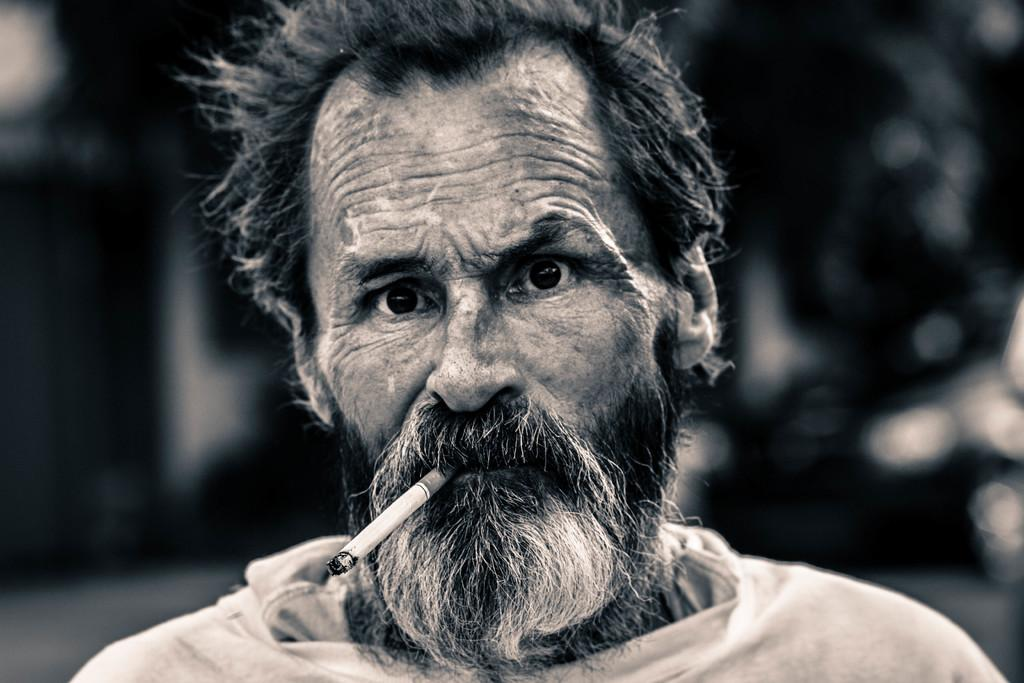What is present in the image? There is a person in the image. What is the person doing in the image? The person is holding a cigarette in their mouth. Can you describe the background of the image? The background of the image is blurred. What type of comb is the monkey using in the image? There is no monkey or comb present in the image. 